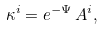<formula> <loc_0><loc_0><loc_500><loc_500>\kappa ^ { i } = e ^ { - \Psi } \, A ^ { i } ,</formula> 